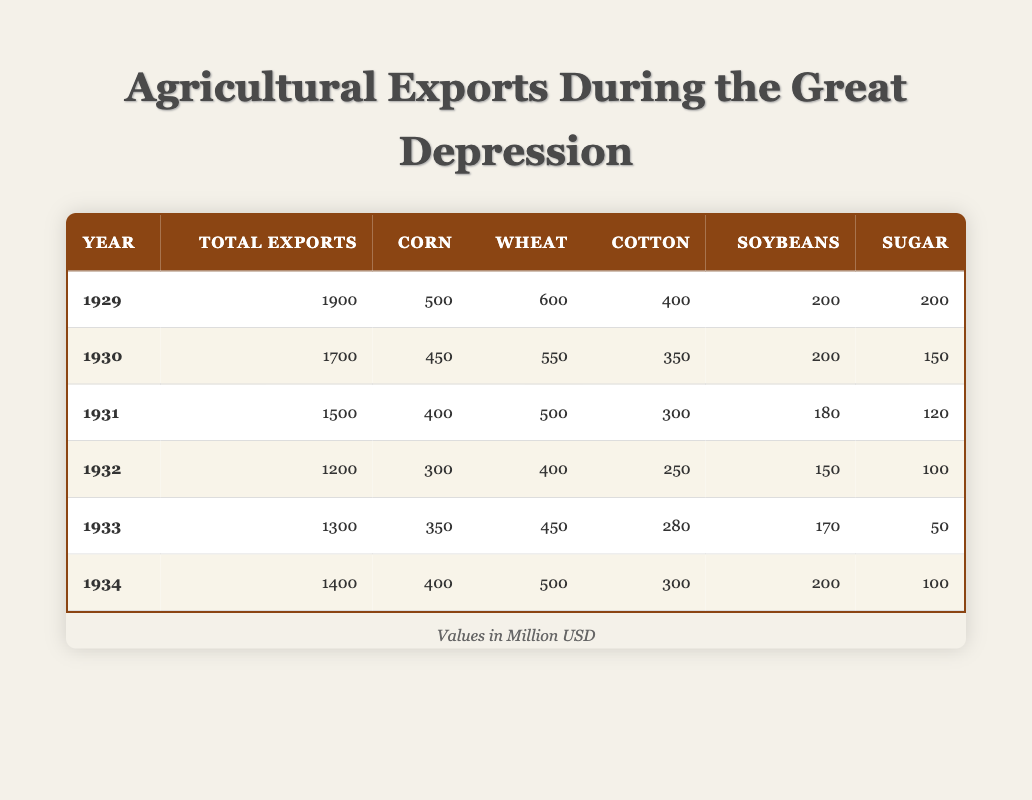What was the total value of agricultural exports in 1929? According to the table, the total exports value for the year 1929 is listed under the corresponding column. The value is 1900 million USD.
Answer: 1900 million USD In which year did wheat exports exceed corn exports? By analyzing the table, the values for wheat and corn exports can be compared across the years. Wheat exports exceeded corn exports in every year from 1929 to 1934. In 1931, for instance, wheat exports were 500 million USD while corn was only 400 million USD.
Answer: From 1931 onwards What was the percentage decrease in total exports from 1929 to 1934? The total export value in 1929 was 1900 million USD and in 1934 it was 1400 million USD. The decrease can be calculated as (1900 - 1400) / 1900 * 100 = 26.32%.
Answer: 26.32% Did cotton exports ever fall below soybeans exports during these years? The table indicates that cotton exports fell below soybeans exports only in the year 1932, where cotton was at 250 million USD and soybeans at 150 million USD. In all other years, cotton exports were higher than soybeans.
Answer: Yes, in 1932 What was the average export value for sugar from 1929 to 1934? To find the average for sugar exports, sum all the sugar export values across the years, which are 200 (1929) + 150 (1930) + 120 (1931) + 100 (1932) + 50 (1933) + 100 (1934) = 720 million USD. Divide that by the number of years (6), to get 720 / 6 = 120 million USD.
Answer: 120 million USD Which year had the highest export value for corn? The table shows that the highest export value for corn is in 1929 with 500 million USD. No other year had higher corn exports than this figure.
Answer: 1929 Was the total export value higher in 1933 than in 1931? By checking the total values, 1933 had 1300 million USD while 1931 had 1500 million USD. Therefore, 1933 did not exceed 1931.
Answer: No What is the change in total exports from 1932 to 1933? The total exports in 1932 were 1200 million USD, and in 1933 they were 1300 million USD. The change can be calculated as 1300 - 1200 = 100 million USD increase.
Answer: 100 million USD increase 